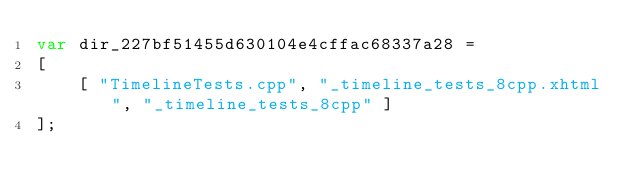Convert code to text. <code><loc_0><loc_0><loc_500><loc_500><_JavaScript_>var dir_227bf51455d630104e4cffac68337a28 =
[
    [ "TimelineTests.cpp", "_timeline_tests_8cpp.xhtml", "_timeline_tests_8cpp" ]
];</code> 